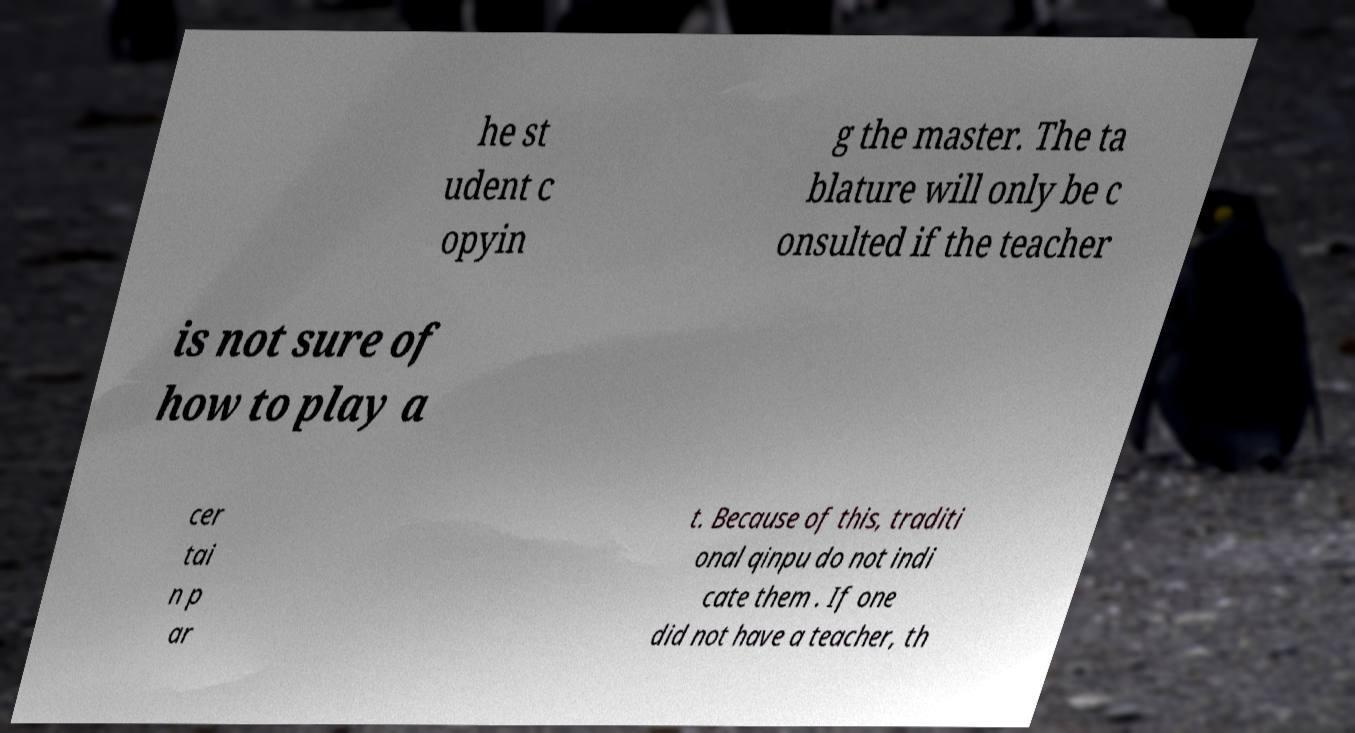Please identify and transcribe the text found in this image. he st udent c opyin g the master. The ta blature will only be c onsulted if the teacher is not sure of how to play a cer tai n p ar t. Because of this, traditi onal qinpu do not indi cate them . If one did not have a teacher, th 